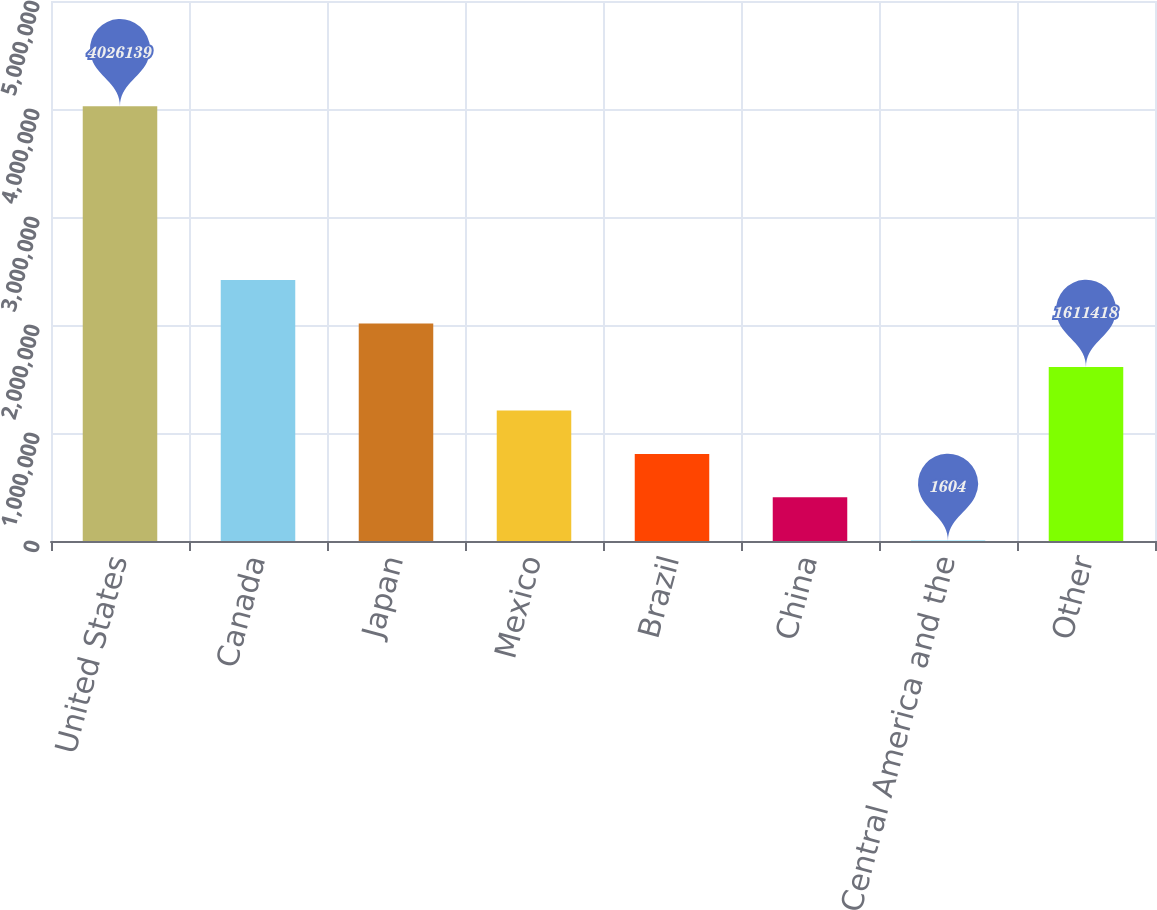<chart> <loc_0><loc_0><loc_500><loc_500><bar_chart><fcel>United States<fcel>Canada<fcel>Japan<fcel>Mexico<fcel>Brazil<fcel>China<fcel>Central America and the<fcel>Other<nl><fcel>4.02614e+06<fcel>2.41632e+06<fcel>2.01387e+06<fcel>1.20896e+06<fcel>806511<fcel>404058<fcel>1604<fcel>1.61142e+06<nl></chart> 